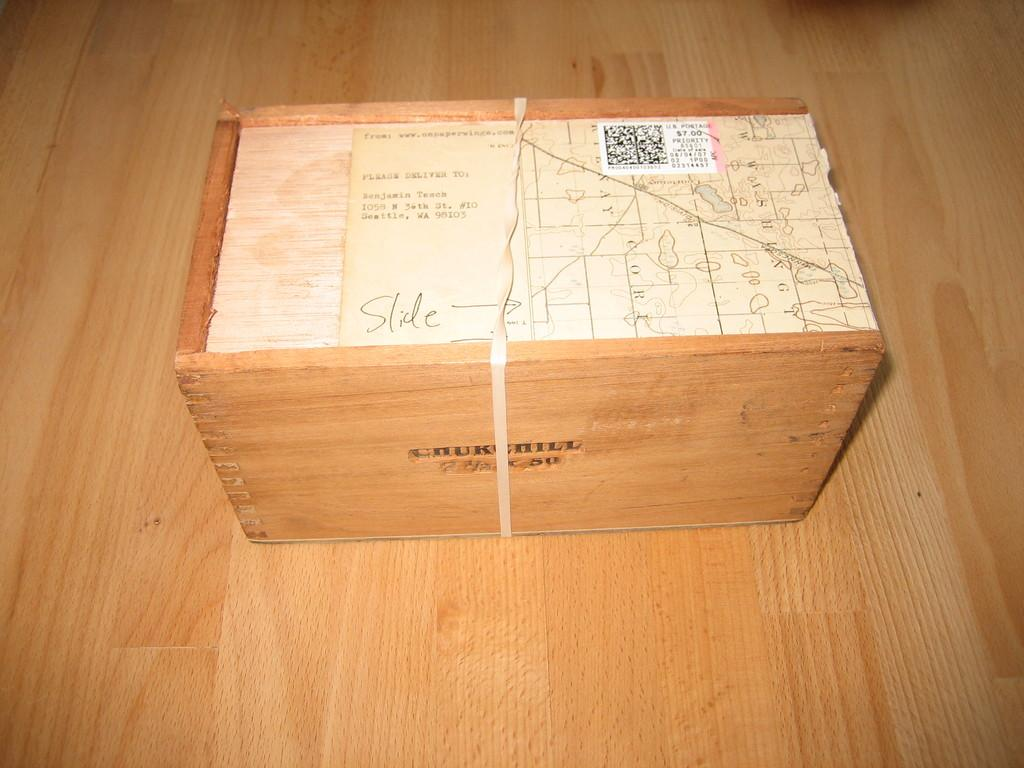<image>
Summarize the visual content of the image. a box that says 'chuckchill' on the side of it in black lettering 